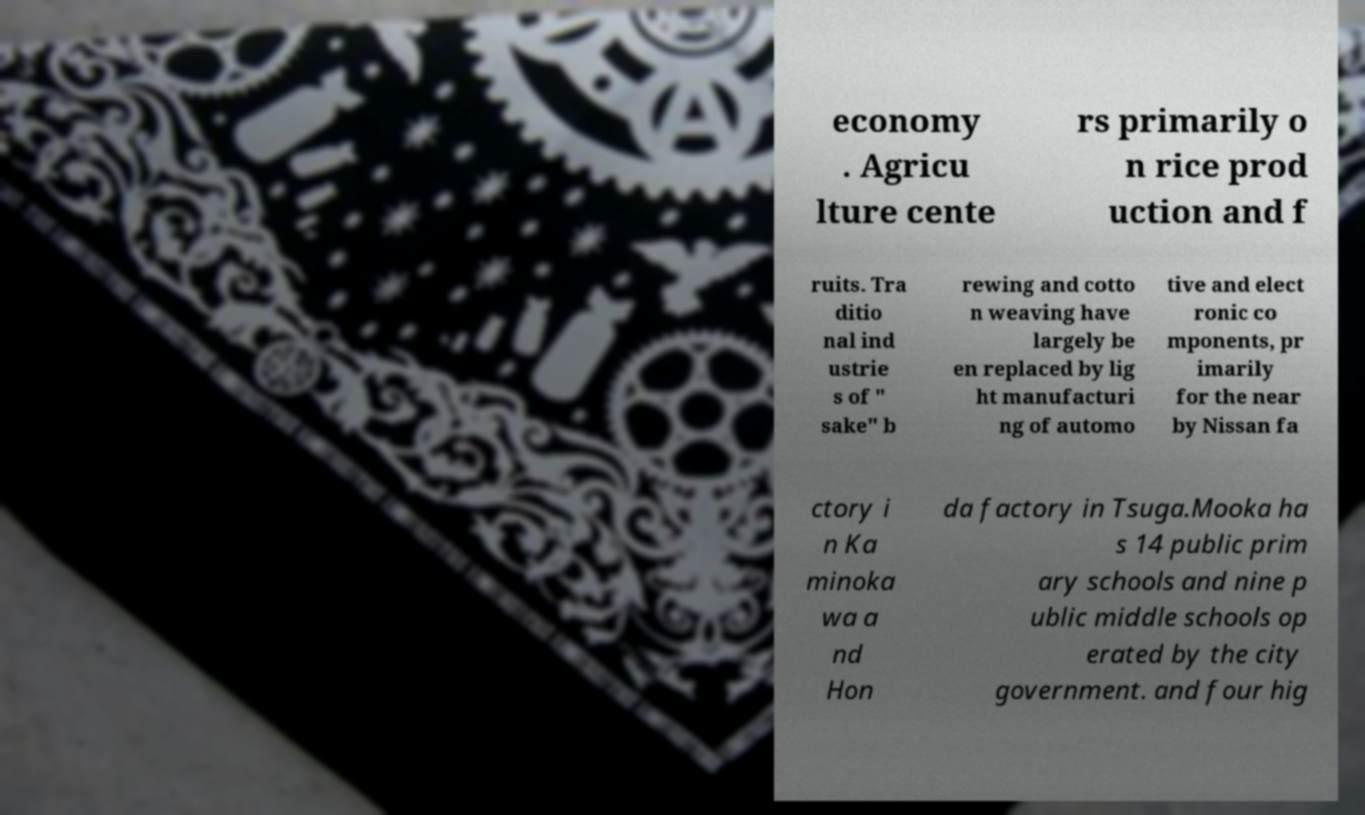There's text embedded in this image that I need extracted. Can you transcribe it verbatim? economy . Agricu lture cente rs primarily o n rice prod uction and f ruits. Tra ditio nal ind ustrie s of " sake" b rewing and cotto n weaving have largely be en replaced by lig ht manufacturi ng of automo tive and elect ronic co mponents, pr imarily for the near by Nissan fa ctory i n Ka minoka wa a nd Hon da factory in Tsuga.Mooka ha s 14 public prim ary schools and nine p ublic middle schools op erated by the city government. and four hig 